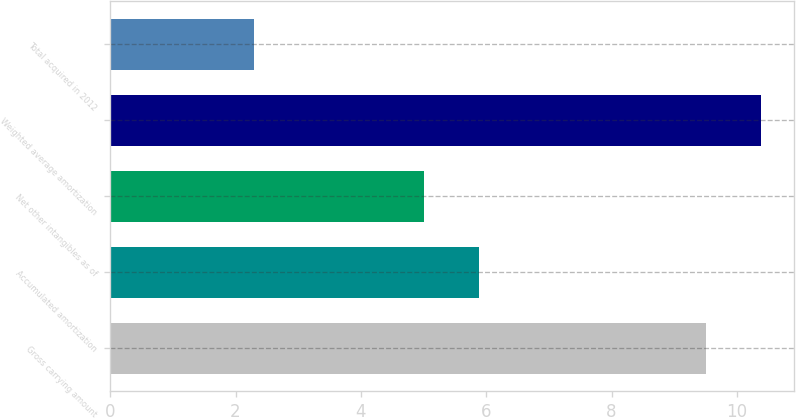Convert chart. <chart><loc_0><loc_0><loc_500><loc_500><bar_chart><fcel>Gross carrying amount<fcel>Accumulated amortization<fcel>Net other intangibles as of<fcel>Weighted average amortization<fcel>Total acquired in 2012<nl><fcel>9.5<fcel>5.89<fcel>5<fcel>10.39<fcel>2.3<nl></chart> 